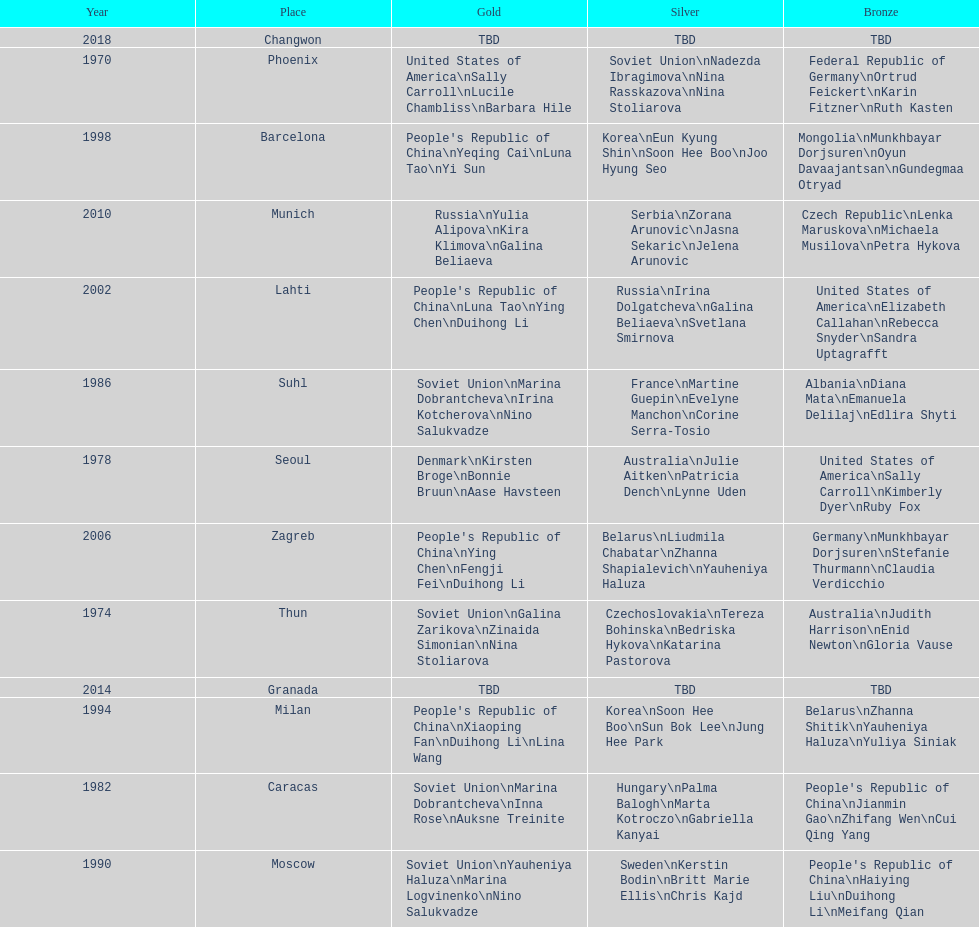Name one of the top three women to earn gold at the 1970 world championship held in phoenix, az Sally Carroll. 